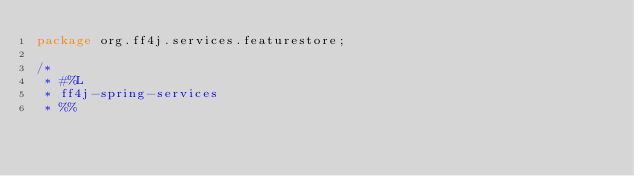<code> <loc_0><loc_0><loc_500><loc_500><_Java_>package org.ff4j.services.featurestore;

/*
 * #%L
 * ff4j-spring-services
 * %%</code> 